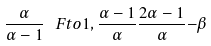<formula> <loc_0><loc_0><loc_500><loc_500>\frac { \alpha } { \alpha - 1 } \, \ F t o { 1 , \frac { \alpha - 1 } { \alpha } } { \frac { 2 \alpha - 1 } { \alpha } } { - \beta }</formula> 